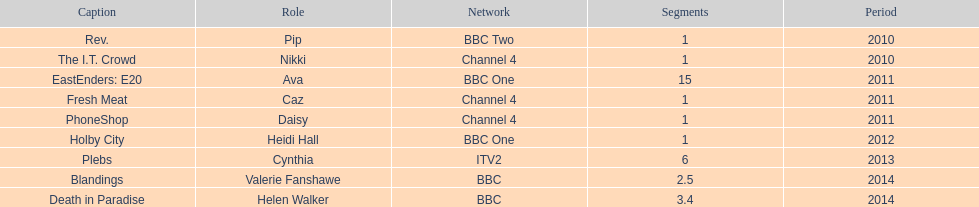Blandings and death in paradise both aired on which broadcaster? BBC. 